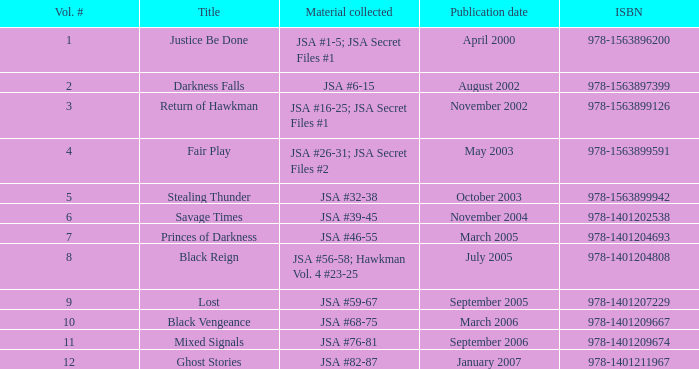How many Volume Numbers have the title of Darkness Falls? 2.0. 